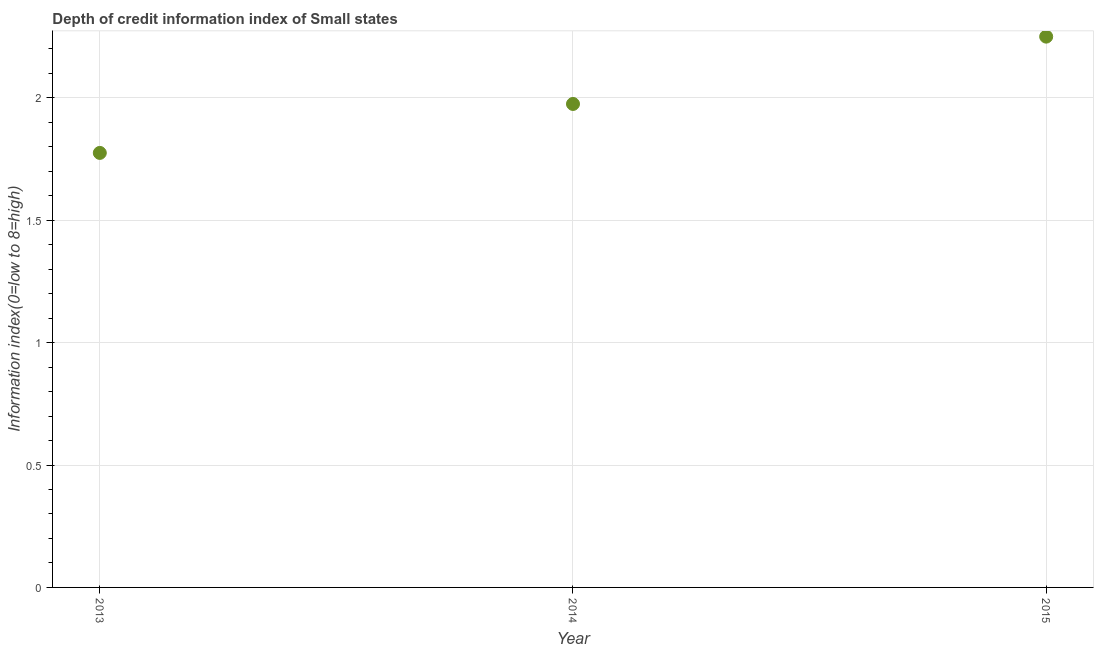What is the depth of credit information index in 2015?
Keep it short and to the point. 2.25. Across all years, what is the maximum depth of credit information index?
Your answer should be compact. 2.25. Across all years, what is the minimum depth of credit information index?
Provide a succinct answer. 1.77. In which year was the depth of credit information index maximum?
Ensure brevity in your answer.  2015. What is the sum of the depth of credit information index?
Ensure brevity in your answer.  6. What is the difference between the depth of credit information index in 2014 and 2015?
Your answer should be very brief. -0.27. What is the median depth of credit information index?
Ensure brevity in your answer.  1.98. What is the ratio of the depth of credit information index in 2013 to that in 2014?
Your answer should be very brief. 0.9. Is the depth of credit information index in 2013 less than that in 2015?
Your answer should be very brief. Yes. Is the difference between the depth of credit information index in 2014 and 2015 greater than the difference between any two years?
Ensure brevity in your answer.  No. What is the difference between the highest and the second highest depth of credit information index?
Your answer should be compact. 0.27. What is the difference between the highest and the lowest depth of credit information index?
Your answer should be very brief. 0.48. In how many years, is the depth of credit information index greater than the average depth of credit information index taken over all years?
Your answer should be very brief. 1. Does the depth of credit information index monotonically increase over the years?
Your answer should be very brief. Yes. How many dotlines are there?
Make the answer very short. 1. Are the values on the major ticks of Y-axis written in scientific E-notation?
Your answer should be very brief. No. Does the graph contain grids?
Offer a very short reply. Yes. What is the title of the graph?
Provide a succinct answer. Depth of credit information index of Small states. What is the label or title of the Y-axis?
Your answer should be compact. Information index(0=low to 8=high). What is the Information index(0=low to 8=high) in 2013?
Your answer should be compact. 1.77. What is the Information index(0=low to 8=high) in 2014?
Offer a very short reply. 1.98. What is the Information index(0=low to 8=high) in 2015?
Offer a very short reply. 2.25. What is the difference between the Information index(0=low to 8=high) in 2013 and 2014?
Keep it short and to the point. -0.2. What is the difference between the Information index(0=low to 8=high) in 2013 and 2015?
Ensure brevity in your answer.  -0.47. What is the difference between the Information index(0=low to 8=high) in 2014 and 2015?
Your answer should be very brief. -0.28. What is the ratio of the Information index(0=low to 8=high) in 2013 to that in 2014?
Keep it short and to the point. 0.9. What is the ratio of the Information index(0=low to 8=high) in 2013 to that in 2015?
Provide a succinct answer. 0.79. What is the ratio of the Information index(0=low to 8=high) in 2014 to that in 2015?
Ensure brevity in your answer.  0.88. 